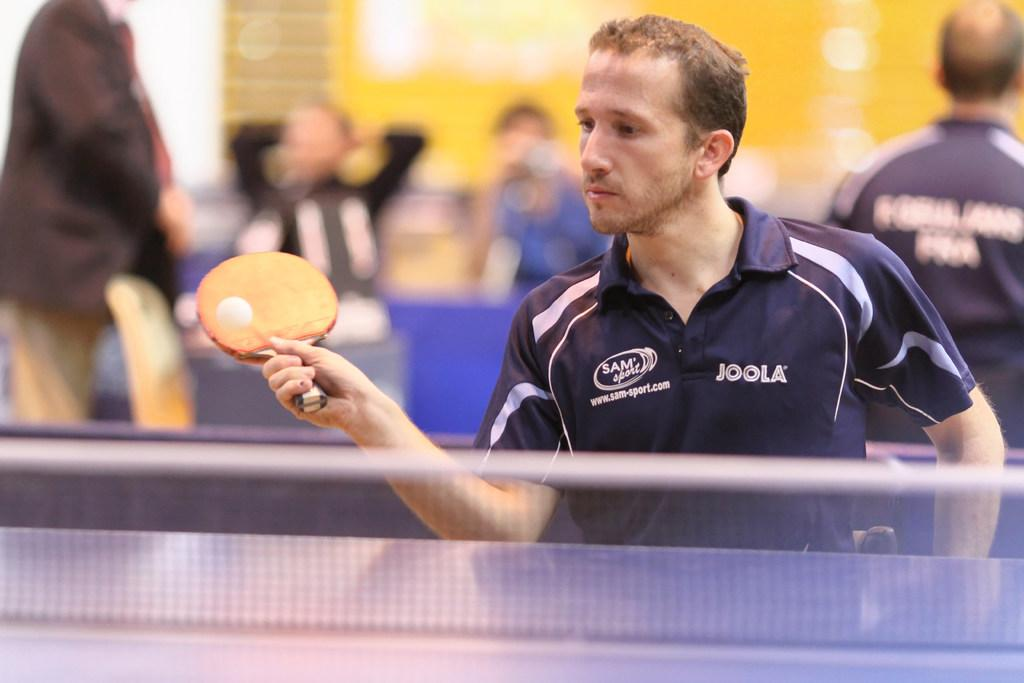Who is the main subject in the image? There is a man in the image. What is the man wearing? The man is wearing a blue t-shirt. What activity is the man engaged in? The man is playing table tennis. What object is the man holding? The man is holding a bat. Are there any other people in the image? Yes, there are other persons behind the man. What type of creature is the man rescuing in the image? There is no creature present in the image, nor is the man depicted as a fireman or rescuing anyone. 